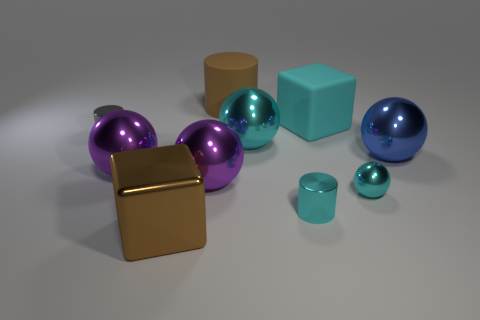There is a metal cylinder that is the same color as the big rubber cube; what size is it?
Give a very brief answer. Small. There is a small ball that is the same color as the rubber block; what material is it?
Keep it short and to the point. Metal. How many cylinders are either blue metallic objects or small objects?
Give a very brief answer. 2. Does the big brown matte object have the same shape as the tiny gray metallic thing?
Your answer should be very brief. Yes. There is a matte object left of the big cyan metallic object; what is its size?
Make the answer very short. Large. Are there any tiny balls of the same color as the matte block?
Offer a terse response. Yes. There is a sphere that is to the left of the brown cube; is its size the same as the large cylinder?
Give a very brief answer. Yes. The matte cylinder has what color?
Keep it short and to the point. Brown. There is a cube in front of the metal cylinder on the left side of the small cyan cylinder; what is its color?
Your response must be concise. Brown. Are there any tiny cyan cylinders made of the same material as the blue thing?
Ensure brevity in your answer.  Yes. 